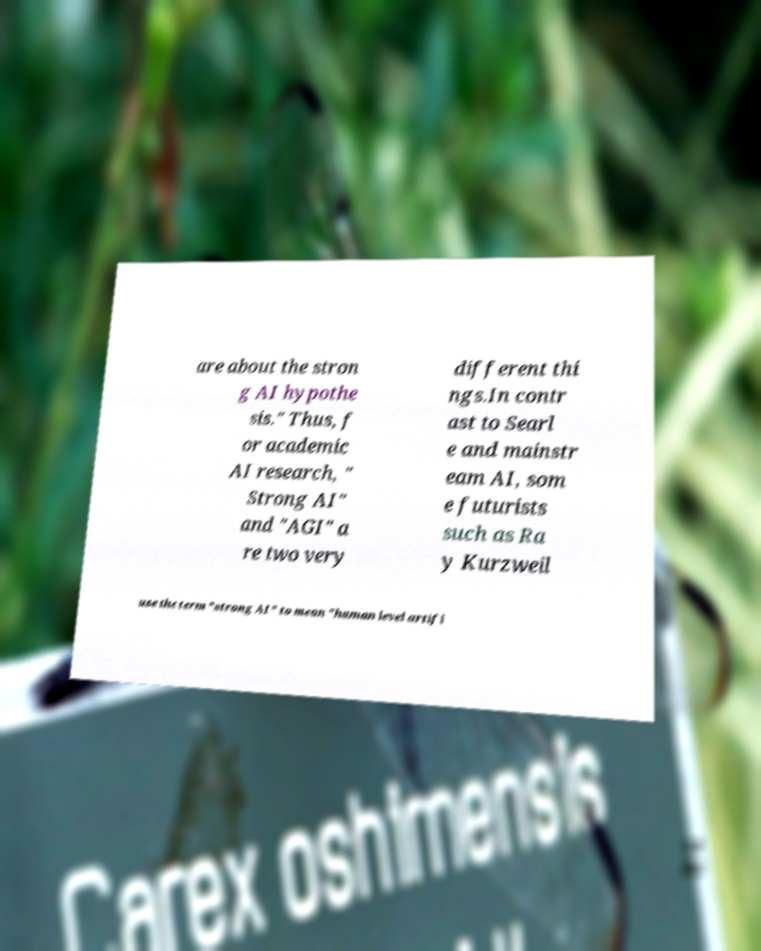What messages or text are displayed in this image? I need them in a readable, typed format. are about the stron g AI hypothe sis." Thus, f or academic AI research, " Strong AI" and "AGI" a re two very different thi ngs.In contr ast to Searl e and mainstr eam AI, som e futurists such as Ra y Kurzweil use the term "strong AI" to mean "human level artifi 